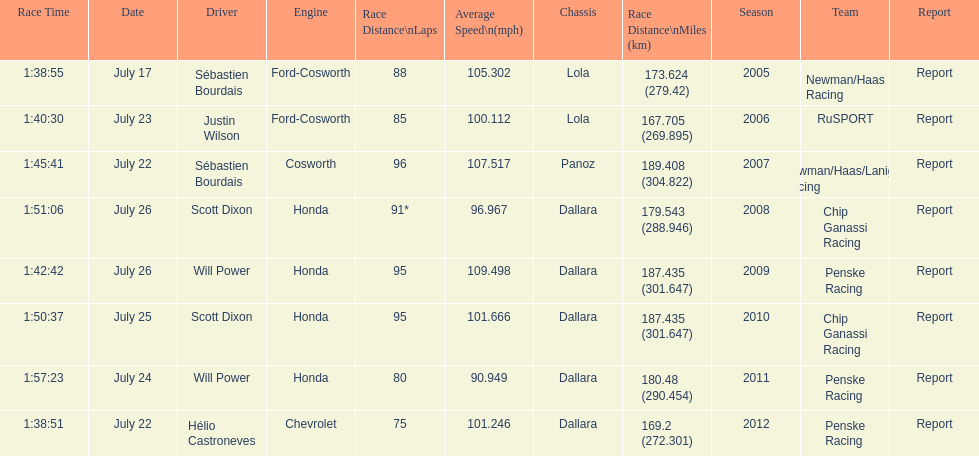How many flags other than france (the first flag) are represented? 3. 